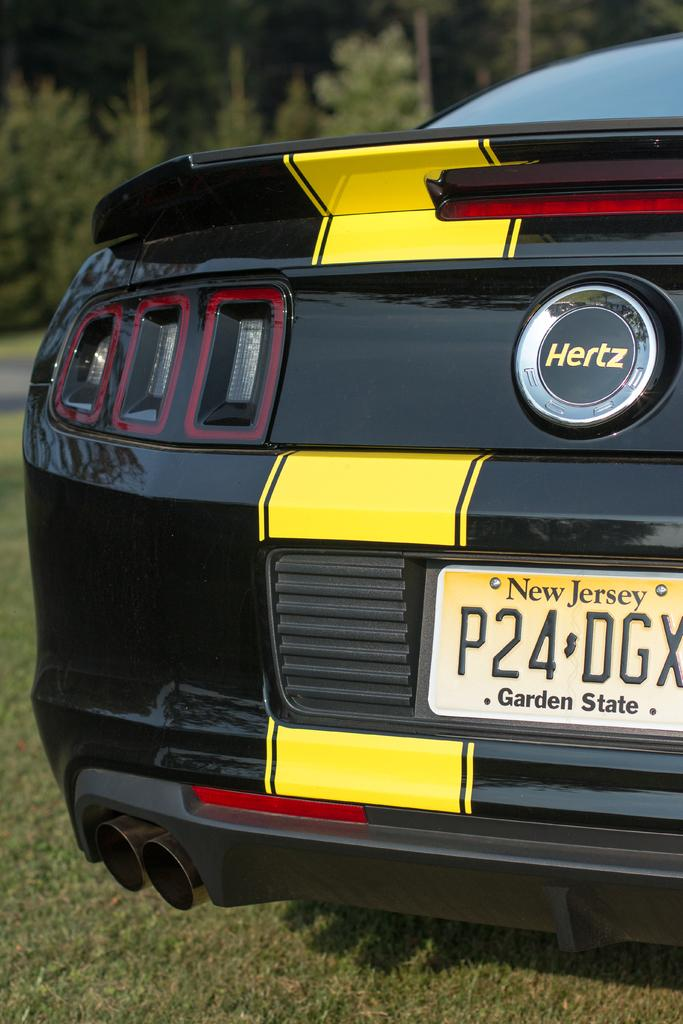What is the main subject of the image? There is a car in the image. Where is the car located? The car is placed on the grass. What can be seen in the background of the image? There are trees visible in the image. Can you tell me how many answers are floating in the ocean in the image? There is no ocean or answers present in the image; it features a car on the grass with trees in the background. 